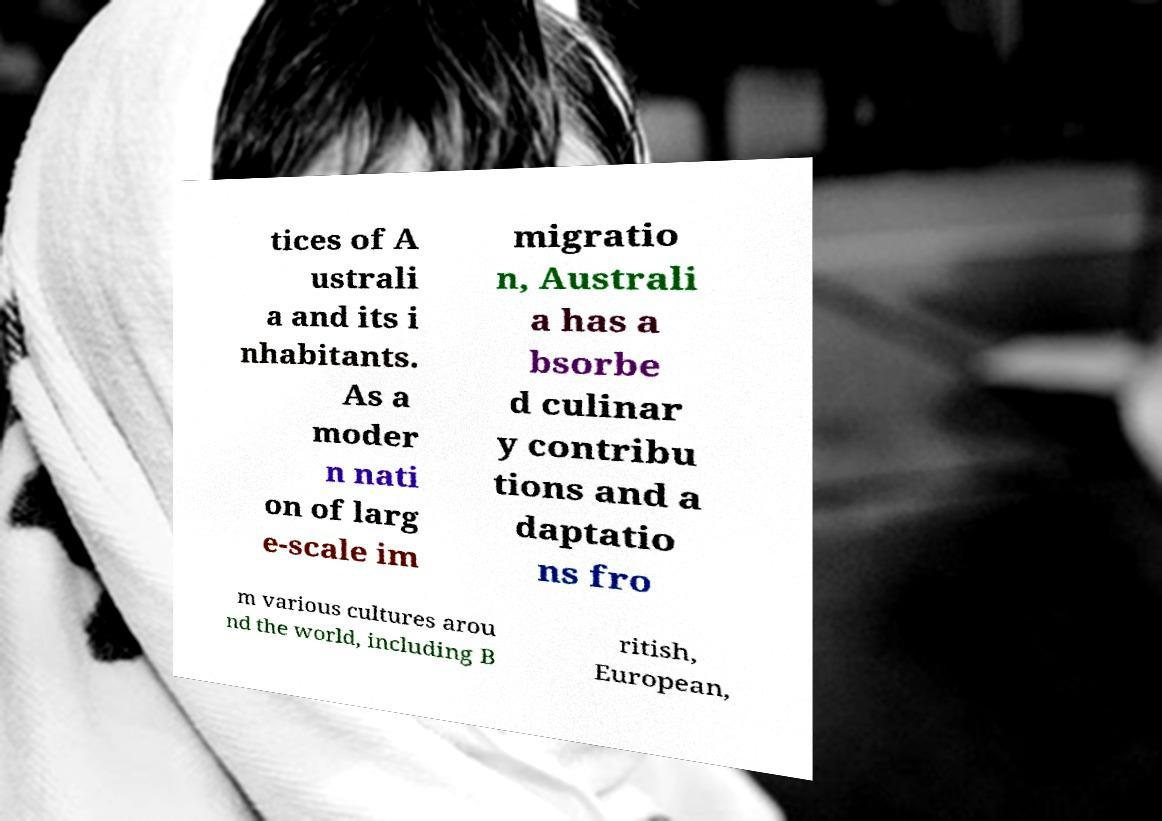There's text embedded in this image that I need extracted. Can you transcribe it verbatim? tices of A ustrali a and its i nhabitants. As a moder n nati on of larg e-scale im migratio n, Australi a has a bsorbe d culinar y contribu tions and a daptatio ns fro m various cultures arou nd the world, including B ritish, European, 